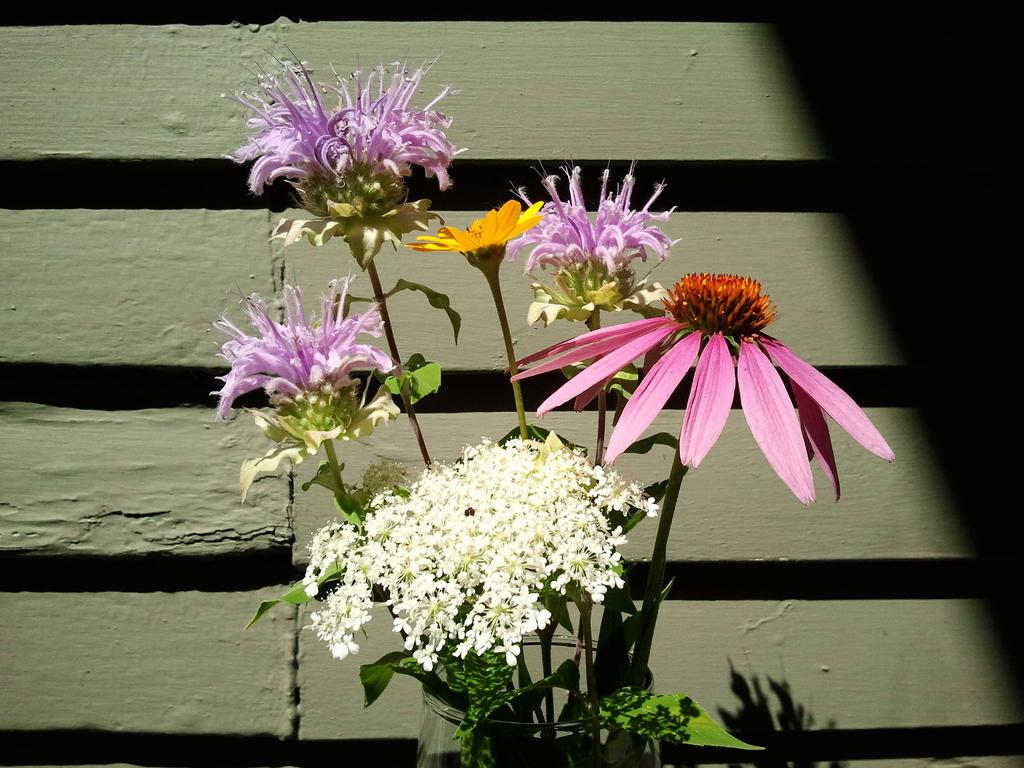What type of living organisms can be seen in the image? There are flowers in the image. How many different colors can be observed in the flowers? The flowers are in different colors: white, yellow, pink, and violet. What is visible in the background of the image? There is a wall in the background of the image. What type of quiver can be seen in the image? There is no quiver present in the image; it features flowers and a wall in the background. How does the ice affect the flowers in the image? There is no ice present in the image, so its effect on the flowers cannot be determined. 